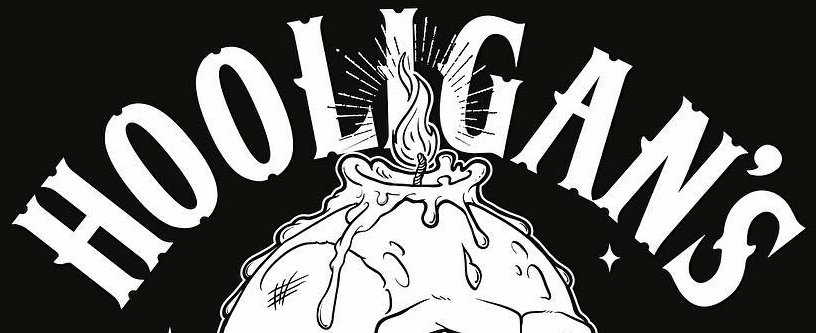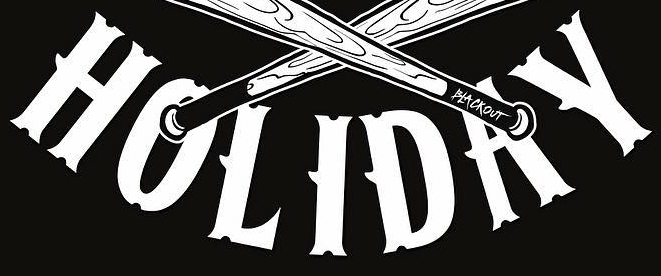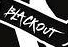What words can you see in these images in sequence, separated by a semicolon? HOOLIGAN'S; HOLIDAY; BLACKOUT 